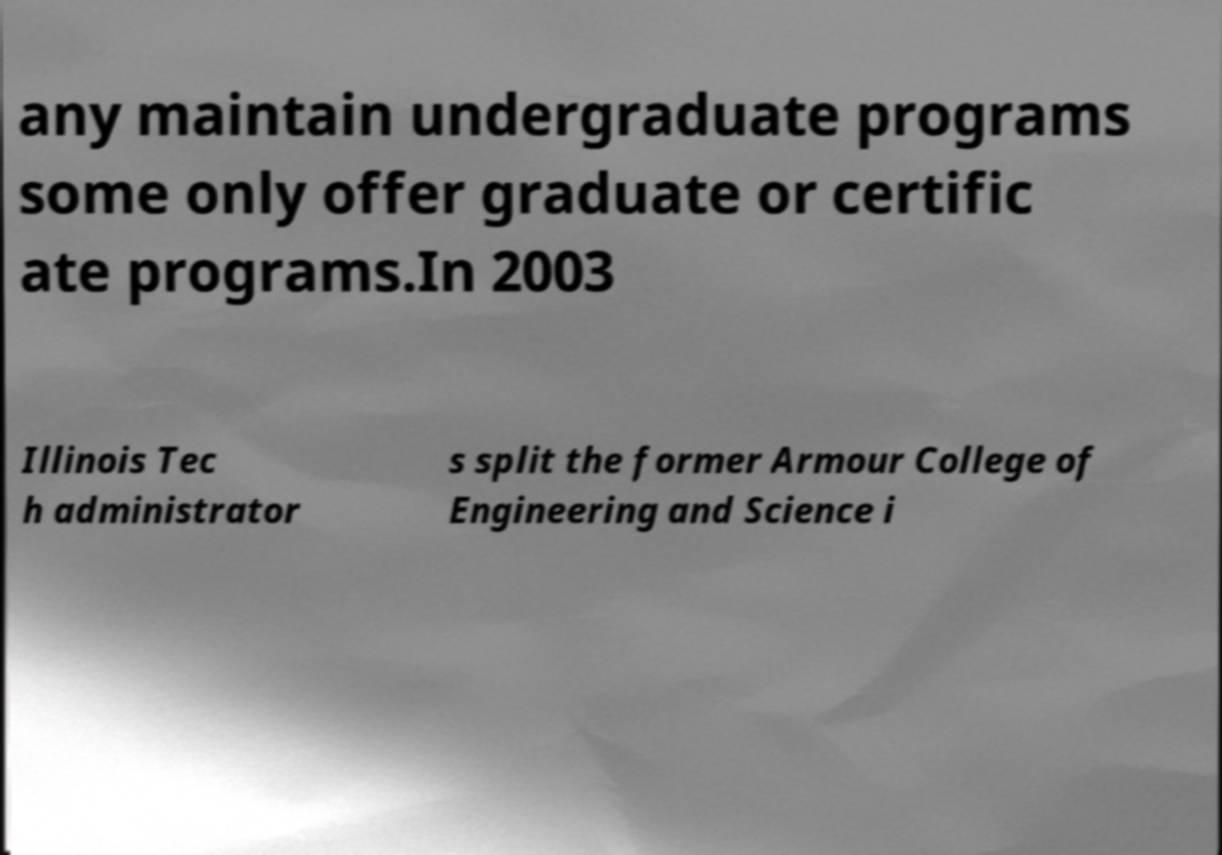Can you accurately transcribe the text from the provided image for me? any maintain undergraduate programs some only offer graduate or certific ate programs.In 2003 Illinois Tec h administrator s split the former Armour College of Engineering and Science i 